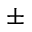<formula> <loc_0><loc_0><loc_500><loc_500>\pm</formula> 